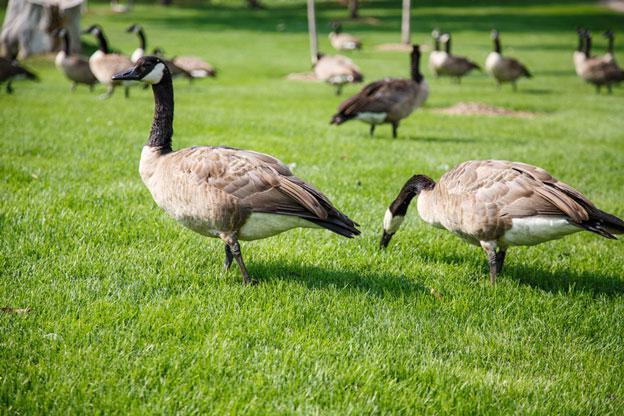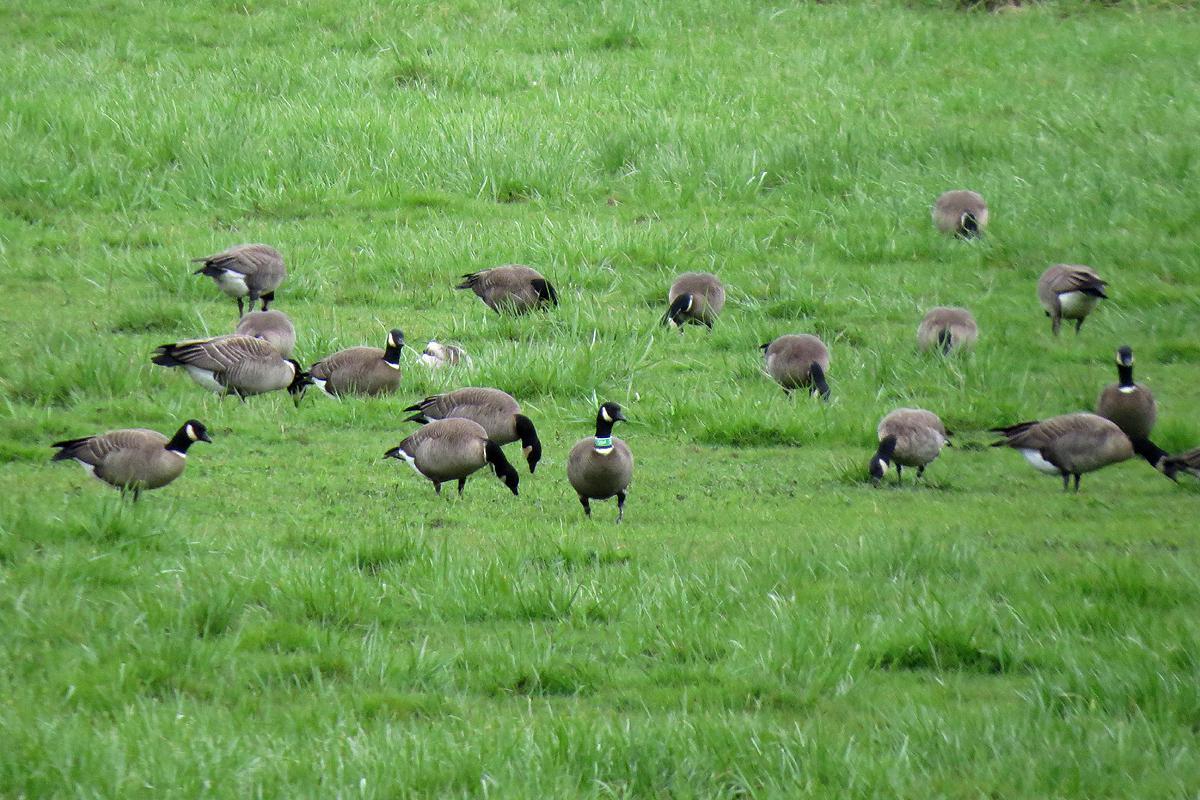The first image is the image on the left, the second image is the image on the right. For the images displayed, is the sentence "There is a person near the birds in one of the images." factually correct? Answer yes or no. No. The first image is the image on the left, the second image is the image on the right. Given the left and right images, does the statement "There is a man among a flock of geese in an outdoor setting" hold true? Answer yes or no. No. 